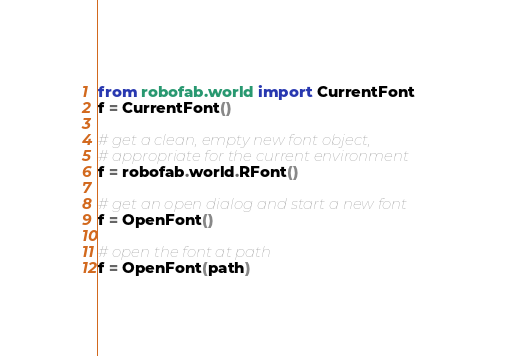Convert code to text. <code><loc_0><loc_0><loc_500><loc_500><_Python_>from robofab.world import CurrentFont
f = CurrentFont()

# get a clean, empty new font object,
# appropriate for the current environment
f = robofab.world.RFont()

# get an open dialog and start a new font
f = OpenFont()

# open the font at path
f = OpenFont(path)</code> 